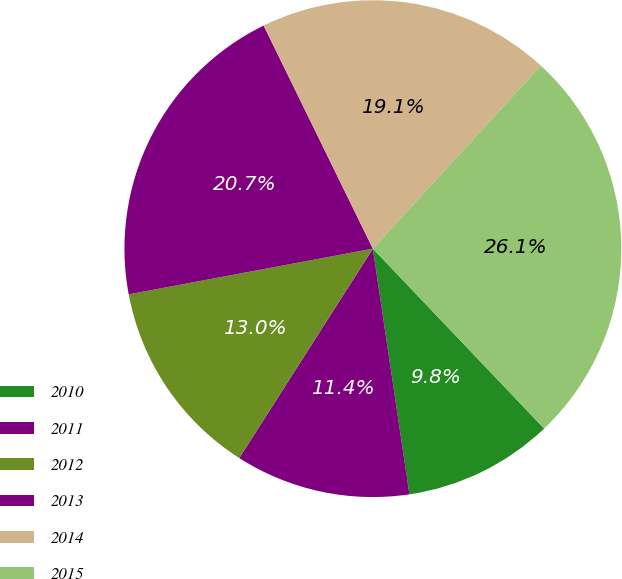Convert chart to OTSL. <chart><loc_0><loc_0><loc_500><loc_500><pie_chart><fcel>2010<fcel>2011<fcel>2012<fcel>2013<fcel>2014<fcel>2015<nl><fcel>9.76%<fcel>11.39%<fcel>13.02%<fcel>20.7%<fcel>19.07%<fcel>26.07%<nl></chart> 